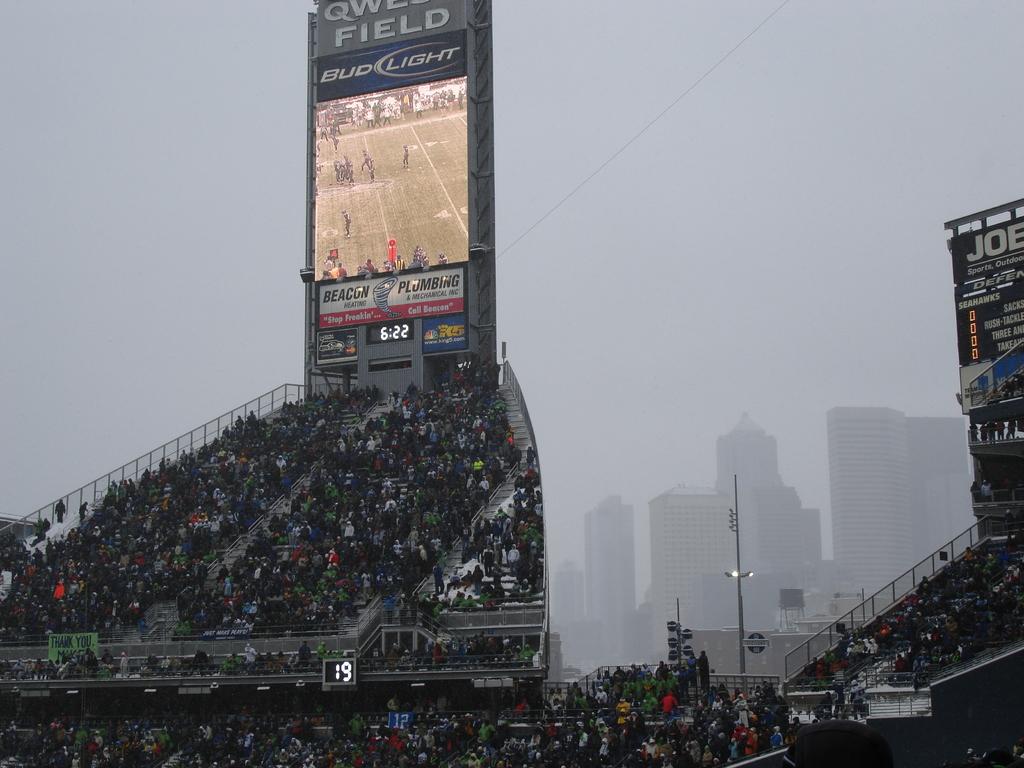Where is this game being played?
Keep it short and to the point. Unanswerable. 